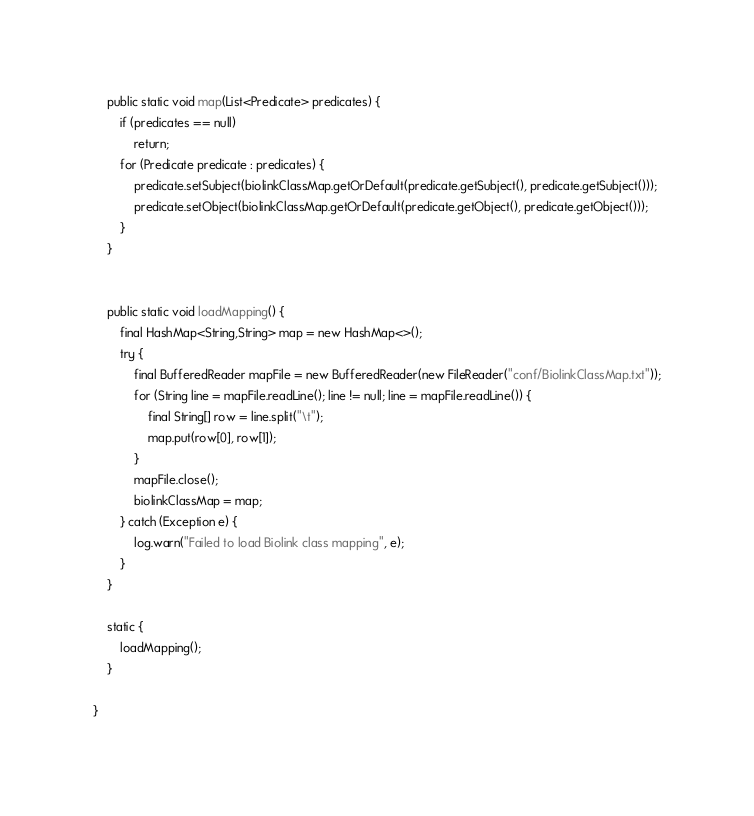Convert code to text. <code><loc_0><loc_0><loc_500><loc_500><_Java_>	public static void map(List<Predicate> predicates) {
		if (predicates == null)
			return;
		for (Predicate predicate : predicates) {
			predicate.setSubject(biolinkClassMap.getOrDefault(predicate.getSubject(), predicate.getSubject()));
			predicate.setObject(biolinkClassMap.getOrDefault(predicate.getObject(), predicate.getObject()));
		}
	}


	public static void loadMapping() {
		final HashMap<String,String> map = new HashMap<>();
		try {
			final BufferedReader mapFile = new BufferedReader(new FileReader("conf/BiolinkClassMap.txt"));
			for (String line = mapFile.readLine(); line != null; line = mapFile.readLine()) {
				final String[] row = line.split("\t");
				map.put(row[0], row[1]);
			}
			mapFile.close();
			biolinkClassMap = map;
		} catch (Exception e) {
			log.warn("Failed to load Biolink class mapping", e);
		}
	}

	static {
		loadMapping();
	}

}
</code> 